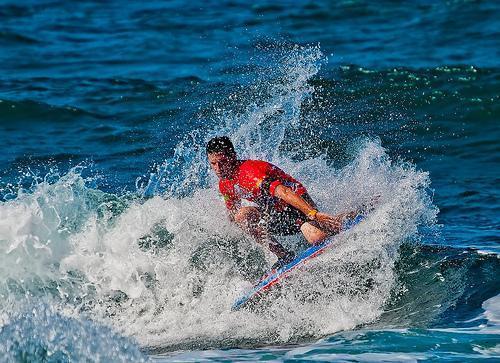How many people are there?
Give a very brief answer. 1. 